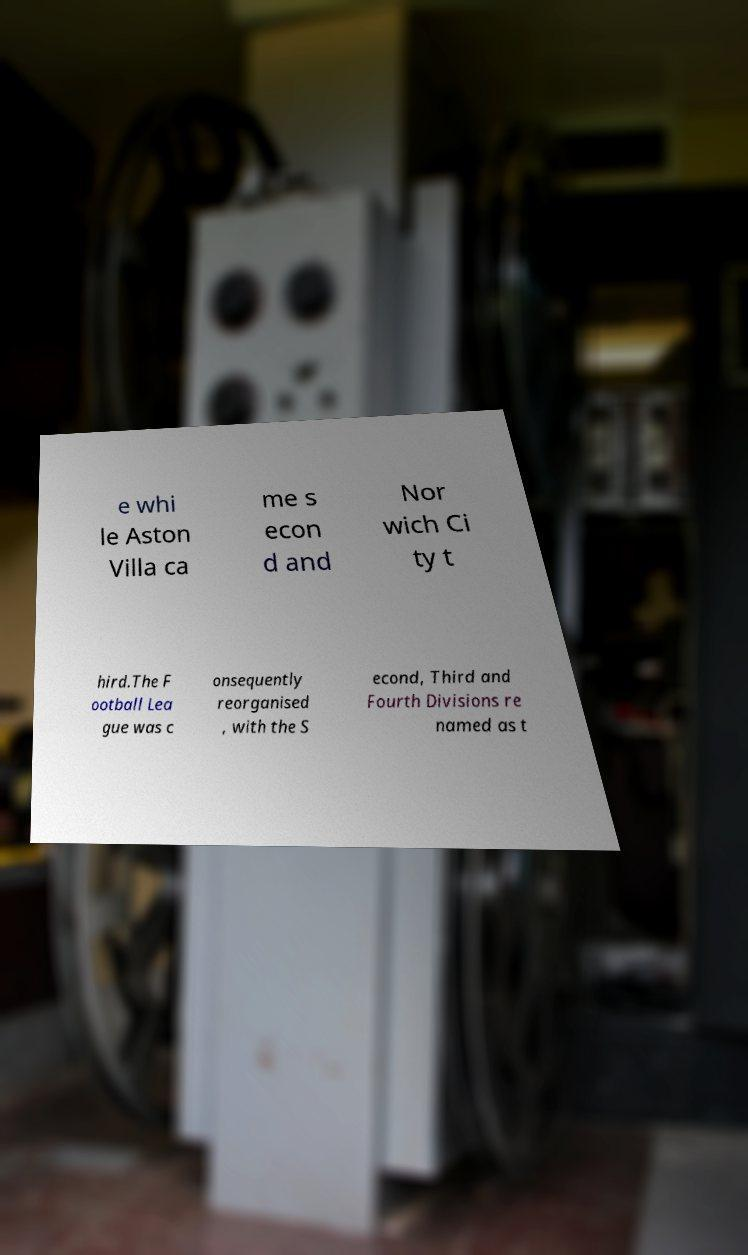Can you read and provide the text displayed in the image?This photo seems to have some interesting text. Can you extract and type it out for me? e whi le Aston Villa ca me s econ d and Nor wich Ci ty t hird.The F ootball Lea gue was c onsequently reorganised , with the S econd, Third and Fourth Divisions re named as t 